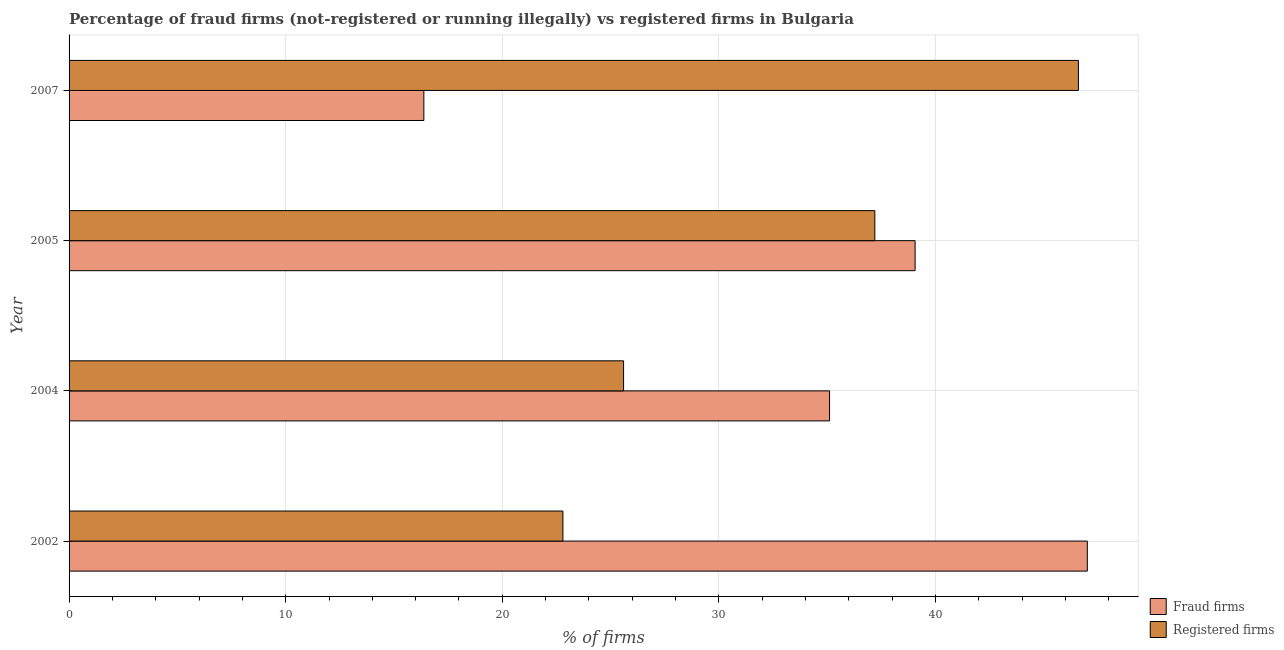How many different coloured bars are there?
Ensure brevity in your answer.  2. How many groups of bars are there?
Your response must be concise. 4. How many bars are there on the 4th tick from the bottom?
Provide a succinct answer. 2. What is the label of the 3rd group of bars from the top?
Offer a terse response. 2004. In how many cases, is the number of bars for a given year not equal to the number of legend labels?
Offer a very short reply. 0. What is the percentage of registered firms in 2004?
Offer a very short reply. 25.6. Across all years, what is the maximum percentage of fraud firms?
Your answer should be compact. 47.01. Across all years, what is the minimum percentage of fraud firms?
Provide a short and direct response. 16.38. What is the total percentage of registered firms in the graph?
Offer a very short reply. 132.2. What is the difference between the percentage of fraud firms in 2002 and that in 2007?
Your answer should be compact. 30.63. What is the difference between the percentage of registered firms in 2005 and the percentage of fraud firms in 2004?
Give a very brief answer. 2.09. What is the average percentage of registered firms per year?
Offer a terse response. 33.05. In the year 2002, what is the difference between the percentage of fraud firms and percentage of registered firms?
Give a very brief answer. 24.21. What is the ratio of the percentage of fraud firms in 2002 to that in 2005?
Keep it short and to the point. 1.2. What is the difference between the highest and the second highest percentage of fraud firms?
Ensure brevity in your answer.  7.95. What is the difference between the highest and the lowest percentage of fraud firms?
Ensure brevity in your answer.  30.63. Is the sum of the percentage of registered firms in 2004 and 2007 greater than the maximum percentage of fraud firms across all years?
Ensure brevity in your answer.  Yes. What does the 1st bar from the top in 2002 represents?
Ensure brevity in your answer.  Registered firms. What does the 1st bar from the bottom in 2005 represents?
Provide a succinct answer. Fraud firms. Are the values on the major ticks of X-axis written in scientific E-notation?
Your response must be concise. No. Does the graph contain any zero values?
Your answer should be very brief. No. Does the graph contain grids?
Offer a very short reply. Yes. Where does the legend appear in the graph?
Provide a short and direct response. Bottom right. How many legend labels are there?
Offer a terse response. 2. What is the title of the graph?
Your response must be concise. Percentage of fraud firms (not-registered or running illegally) vs registered firms in Bulgaria. What is the label or title of the X-axis?
Offer a very short reply. % of firms. What is the label or title of the Y-axis?
Make the answer very short. Year. What is the % of firms in Fraud firms in 2002?
Keep it short and to the point. 47.01. What is the % of firms in Registered firms in 2002?
Give a very brief answer. 22.8. What is the % of firms of Fraud firms in 2004?
Keep it short and to the point. 35.11. What is the % of firms of Registered firms in 2004?
Offer a very short reply. 25.6. What is the % of firms of Fraud firms in 2005?
Make the answer very short. 39.06. What is the % of firms of Registered firms in 2005?
Offer a terse response. 37.2. What is the % of firms in Fraud firms in 2007?
Ensure brevity in your answer.  16.38. What is the % of firms of Registered firms in 2007?
Offer a terse response. 46.6. Across all years, what is the maximum % of firms of Fraud firms?
Your response must be concise. 47.01. Across all years, what is the maximum % of firms of Registered firms?
Provide a succinct answer. 46.6. Across all years, what is the minimum % of firms of Fraud firms?
Keep it short and to the point. 16.38. Across all years, what is the minimum % of firms in Registered firms?
Ensure brevity in your answer.  22.8. What is the total % of firms in Fraud firms in the graph?
Keep it short and to the point. 137.56. What is the total % of firms in Registered firms in the graph?
Your response must be concise. 132.2. What is the difference between the % of firms of Fraud firms in 2002 and that in 2004?
Ensure brevity in your answer.  11.9. What is the difference between the % of firms in Registered firms in 2002 and that in 2004?
Give a very brief answer. -2.8. What is the difference between the % of firms in Fraud firms in 2002 and that in 2005?
Offer a terse response. 7.95. What is the difference between the % of firms in Registered firms in 2002 and that in 2005?
Make the answer very short. -14.4. What is the difference between the % of firms in Fraud firms in 2002 and that in 2007?
Keep it short and to the point. 30.63. What is the difference between the % of firms of Registered firms in 2002 and that in 2007?
Provide a succinct answer. -23.8. What is the difference between the % of firms in Fraud firms in 2004 and that in 2005?
Keep it short and to the point. -3.95. What is the difference between the % of firms in Registered firms in 2004 and that in 2005?
Your answer should be very brief. -11.6. What is the difference between the % of firms in Fraud firms in 2004 and that in 2007?
Give a very brief answer. 18.73. What is the difference between the % of firms of Fraud firms in 2005 and that in 2007?
Provide a succinct answer. 22.68. What is the difference between the % of firms in Fraud firms in 2002 and the % of firms in Registered firms in 2004?
Give a very brief answer. 21.41. What is the difference between the % of firms of Fraud firms in 2002 and the % of firms of Registered firms in 2005?
Give a very brief answer. 9.81. What is the difference between the % of firms of Fraud firms in 2002 and the % of firms of Registered firms in 2007?
Ensure brevity in your answer.  0.41. What is the difference between the % of firms in Fraud firms in 2004 and the % of firms in Registered firms in 2005?
Provide a short and direct response. -2.09. What is the difference between the % of firms of Fraud firms in 2004 and the % of firms of Registered firms in 2007?
Your answer should be very brief. -11.49. What is the difference between the % of firms of Fraud firms in 2005 and the % of firms of Registered firms in 2007?
Your answer should be compact. -7.54. What is the average % of firms of Fraud firms per year?
Keep it short and to the point. 34.39. What is the average % of firms of Registered firms per year?
Make the answer very short. 33.05. In the year 2002, what is the difference between the % of firms of Fraud firms and % of firms of Registered firms?
Give a very brief answer. 24.21. In the year 2004, what is the difference between the % of firms of Fraud firms and % of firms of Registered firms?
Ensure brevity in your answer.  9.51. In the year 2005, what is the difference between the % of firms of Fraud firms and % of firms of Registered firms?
Your answer should be very brief. 1.86. In the year 2007, what is the difference between the % of firms of Fraud firms and % of firms of Registered firms?
Your answer should be compact. -30.22. What is the ratio of the % of firms of Fraud firms in 2002 to that in 2004?
Offer a terse response. 1.34. What is the ratio of the % of firms in Registered firms in 2002 to that in 2004?
Your answer should be compact. 0.89. What is the ratio of the % of firms of Fraud firms in 2002 to that in 2005?
Offer a terse response. 1.2. What is the ratio of the % of firms of Registered firms in 2002 to that in 2005?
Provide a short and direct response. 0.61. What is the ratio of the % of firms of Fraud firms in 2002 to that in 2007?
Offer a very short reply. 2.87. What is the ratio of the % of firms of Registered firms in 2002 to that in 2007?
Provide a short and direct response. 0.49. What is the ratio of the % of firms in Fraud firms in 2004 to that in 2005?
Ensure brevity in your answer.  0.9. What is the ratio of the % of firms of Registered firms in 2004 to that in 2005?
Offer a very short reply. 0.69. What is the ratio of the % of firms of Fraud firms in 2004 to that in 2007?
Offer a terse response. 2.14. What is the ratio of the % of firms in Registered firms in 2004 to that in 2007?
Offer a very short reply. 0.55. What is the ratio of the % of firms in Fraud firms in 2005 to that in 2007?
Provide a short and direct response. 2.38. What is the ratio of the % of firms in Registered firms in 2005 to that in 2007?
Offer a terse response. 0.8. What is the difference between the highest and the second highest % of firms of Fraud firms?
Ensure brevity in your answer.  7.95. What is the difference between the highest and the lowest % of firms in Fraud firms?
Keep it short and to the point. 30.63. What is the difference between the highest and the lowest % of firms of Registered firms?
Ensure brevity in your answer.  23.8. 